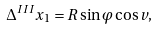<formula> <loc_0><loc_0><loc_500><loc_500>\Delta ^ { I I I } x _ { 1 } = R \sin \varphi \cos v ,</formula> 